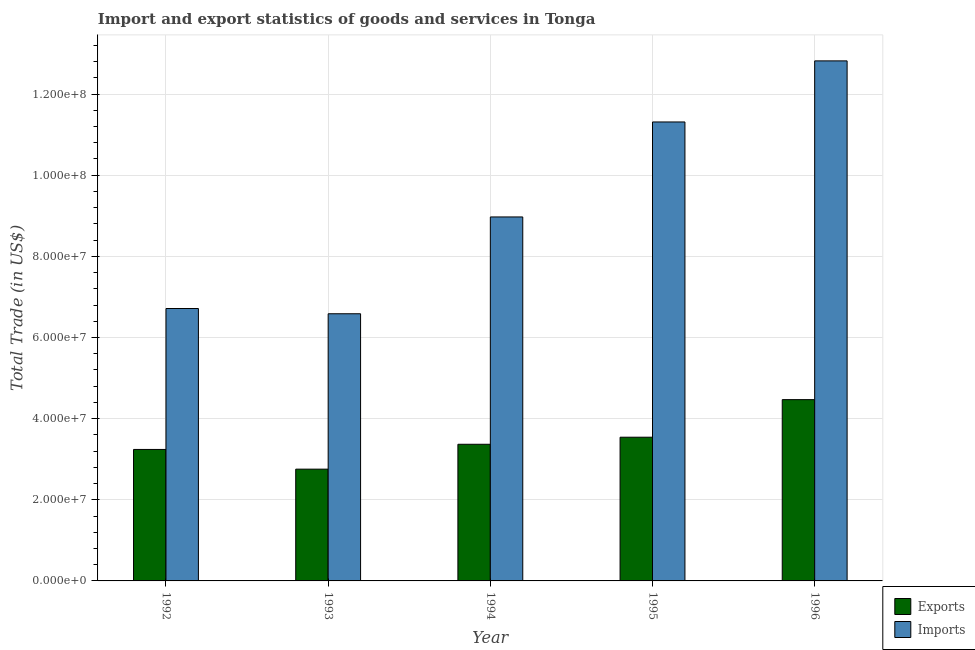Are the number of bars per tick equal to the number of legend labels?
Ensure brevity in your answer.  Yes. How many bars are there on the 1st tick from the left?
Ensure brevity in your answer.  2. How many bars are there on the 3rd tick from the right?
Your response must be concise. 2. What is the imports of goods and services in 1993?
Ensure brevity in your answer.  6.59e+07. Across all years, what is the maximum imports of goods and services?
Make the answer very short. 1.28e+08. Across all years, what is the minimum export of goods and services?
Keep it short and to the point. 2.76e+07. What is the total export of goods and services in the graph?
Offer a terse response. 1.74e+08. What is the difference between the imports of goods and services in 1993 and that in 1996?
Give a very brief answer. -6.23e+07. What is the difference between the export of goods and services in 1994 and the imports of goods and services in 1996?
Offer a very short reply. -1.10e+07. What is the average imports of goods and services per year?
Your response must be concise. 9.28e+07. In how many years, is the imports of goods and services greater than 20000000 US$?
Your answer should be very brief. 5. What is the ratio of the export of goods and services in 1995 to that in 1996?
Make the answer very short. 0.79. Is the export of goods and services in 1995 less than that in 1996?
Give a very brief answer. Yes. What is the difference between the highest and the second highest imports of goods and services?
Keep it short and to the point. 1.51e+07. What is the difference between the highest and the lowest imports of goods and services?
Offer a terse response. 6.23e+07. In how many years, is the export of goods and services greater than the average export of goods and services taken over all years?
Provide a short and direct response. 2. Is the sum of the imports of goods and services in 1992 and 1996 greater than the maximum export of goods and services across all years?
Your response must be concise. Yes. What does the 2nd bar from the left in 1992 represents?
Your answer should be compact. Imports. What does the 1st bar from the right in 1996 represents?
Your answer should be very brief. Imports. How many bars are there?
Your answer should be compact. 10. How many years are there in the graph?
Your response must be concise. 5. Are the values on the major ticks of Y-axis written in scientific E-notation?
Your answer should be compact. Yes. How many legend labels are there?
Ensure brevity in your answer.  2. How are the legend labels stacked?
Provide a short and direct response. Vertical. What is the title of the graph?
Ensure brevity in your answer.  Import and export statistics of goods and services in Tonga. What is the label or title of the Y-axis?
Keep it short and to the point. Total Trade (in US$). What is the Total Trade (in US$) of Exports in 1992?
Provide a succinct answer. 3.24e+07. What is the Total Trade (in US$) in Imports in 1992?
Provide a short and direct response. 6.71e+07. What is the Total Trade (in US$) in Exports in 1993?
Your answer should be very brief. 2.76e+07. What is the Total Trade (in US$) in Imports in 1993?
Offer a very short reply. 6.59e+07. What is the Total Trade (in US$) in Exports in 1994?
Provide a succinct answer. 3.37e+07. What is the Total Trade (in US$) of Imports in 1994?
Your answer should be very brief. 8.97e+07. What is the Total Trade (in US$) in Exports in 1995?
Offer a very short reply. 3.54e+07. What is the Total Trade (in US$) in Imports in 1995?
Your answer should be very brief. 1.13e+08. What is the Total Trade (in US$) in Exports in 1996?
Your response must be concise. 4.47e+07. What is the Total Trade (in US$) in Imports in 1996?
Offer a terse response. 1.28e+08. Across all years, what is the maximum Total Trade (in US$) of Exports?
Offer a very short reply. 4.47e+07. Across all years, what is the maximum Total Trade (in US$) of Imports?
Make the answer very short. 1.28e+08. Across all years, what is the minimum Total Trade (in US$) in Exports?
Offer a very short reply. 2.76e+07. Across all years, what is the minimum Total Trade (in US$) in Imports?
Make the answer very short. 6.59e+07. What is the total Total Trade (in US$) in Exports in the graph?
Ensure brevity in your answer.  1.74e+08. What is the total Total Trade (in US$) in Imports in the graph?
Offer a very short reply. 4.64e+08. What is the difference between the Total Trade (in US$) of Exports in 1992 and that in 1993?
Ensure brevity in your answer.  4.85e+06. What is the difference between the Total Trade (in US$) of Imports in 1992 and that in 1993?
Your answer should be very brief. 1.30e+06. What is the difference between the Total Trade (in US$) in Exports in 1992 and that in 1994?
Offer a very short reply. -1.28e+06. What is the difference between the Total Trade (in US$) of Imports in 1992 and that in 1994?
Provide a short and direct response. -2.26e+07. What is the difference between the Total Trade (in US$) in Exports in 1992 and that in 1995?
Give a very brief answer. -3.02e+06. What is the difference between the Total Trade (in US$) of Imports in 1992 and that in 1995?
Ensure brevity in your answer.  -4.60e+07. What is the difference between the Total Trade (in US$) of Exports in 1992 and that in 1996?
Offer a terse response. -1.23e+07. What is the difference between the Total Trade (in US$) in Imports in 1992 and that in 1996?
Make the answer very short. -6.10e+07. What is the difference between the Total Trade (in US$) in Exports in 1993 and that in 1994?
Ensure brevity in your answer.  -6.13e+06. What is the difference between the Total Trade (in US$) in Imports in 1993 and that in 1994?
Your answer should be very brief. -2.39e+07. What is the difference between the Total Trade (in US$) in Exports in 1993 and that in 1995?
Make the answer very short. -7.87e+06. What is the difference between the Total Trade (in US$) in Imports in 1993 and that in 1995?
Your answer should be very brief. -4.73e+07. What is the difference between the Total Trade (in US$) of Exports in 1993 and that in 1996?
Make the answer very short. -1.71e+07. What is the difference between the Total Trade (in US$) in Imports in 1993 and that in 1996?
Offer a terse response. -6.23e+07. What is the difference between the Total Trade (in US$) in Exports in 1994 and that in 1995?
Your response must be concise. -1.74e+06. What is the difference between the Total Trade (in US$) in Imports in 1994 and that in 1995?
Your response must be concise. -2.34e+07. What is the difference between the Total Trade (in US$) of Exports in 1994 and that in 1996?
Make the answer very short. -1.10e+07. What is the difference between the Total Trade (in US$) of Imports in 1994 and that in 1996?
Give a very brief answer. -3.85e+07. What is the difference between the Total Trade (in US$) in Exports in 1995 and that in 1996?
Make the answer very short. -9.26e+06. What is the difference between the Total Trade (in US$) of Imports in 1995 and that in 1996?
Your response must be concise. -1.51e+07. What is the difference between the Total Trade (in US$) of Exports in 1992 and the Total Trade (in US$) of Imports in 1993?
Make the answer very short. -3.34e+07. What is the difference between the Total Trade (in US$) of Exports in 1992 and the Total Trade (in US$) of Imports in 1994?
Make the answer very short. -5.73e+07. What is the difference between the Total Trade (in US$) of Exports in 1992 and the Total Trade (in US$) of Imports in 1995?
Ensure brevity in your answer.  -8.07e+07. What is the difference between the Total Trade (in US$) in Exports in 1992 and the Total Trade (in US$) in Imports in 1996?
Ensure brevity in your answer.  -9.58e+07. What is the difference between the Total Trade (in US$) in Exports in 1993 and the Total Trade (in US$) in Imports in 1994?
Offer a very short reply. -6.22e+07. What is the difference between the Total Trade (in US$) of Exports in 1993 and the Total Trade (in US$) of Imports in 1995?
Your answer should be very brief. -8.56e+07. What is the difference between the Total Trade (in US$) in Exports in 1993 and the Total Trade (in US$) in Imports in 1996?
Offer a very short reply. -1.01e+08. What is the difference between the Total Trade (in US$) in Exports in 1994 and the Total Trade (in US$) in Imports in 1995?
Make the answer very short. -7.94e+07. What is the difference between the Total Trade (in US$) of Exports in 1994 and the Total Trade (in US$) of Imports in 1996?
Provide a succinct answer. -9.45e+07. What is the difference between the Total Trade (in US$) of Exports in 1995 and the Total Trade (in US$) of Imports in 1996?
Provide a short and direct response. -9.28e+07. What is the average Total Trade (in US$) of Exports per year?
Offer a very short reply. 3.47e+07. What is the average Total Trade (in US$) of Imports per year?
Provide a short and direct response. 9.28e+07. In the year 1992, what is the difference between the Total Trade (in US$) in Exports and Total Trade (in US$) in Imports?
Make the answer very short. -3.47e+07. In the year 1993, what is the difference between the Total Trade (in US$) of Exports and Total Trade (in US$) of Imports?
Provide a short and direct response. -3.83e+07. In the year 1994, what is the difference between the Total Trade (in US$) in Exports and Total Trade (in US$) in Imports?
Keep it short and to the point. -5.60e+07. In the year 1995, what is the difference between the Total Trade (in US$) in Exports and Total Trade (in US$) in Imports?
Provide a succinct answer. -7.77e+07. In the year 1996, what is the difference between the Total Trade (in US$) in Exports and Total Trade (in US$) in Imports?
Offer a terse response. -8.35e+07. What is the ratio of the Total Trade (in US$) of Exports in 1992 to that in 1993?
Offer a very short reply. 1.18. What is the ratio of the Total Trade (in US$) in Imports in 1992 to that in 1993?
Your response must be concise. 1.02. What is the ratio of the Total Trade (in US$) in Exports in 1992 to that in 1994?
Make the answer very short. 0.96. What is the ratio of the Total Trade (in US$) of Imports in 1992 to that in 1994?
Make the answer very short. 0.75. What is the ratio of the Total Trade (in US$) of Exports in 1992 to that in 1995?
Your answer should be very brief. 0.91. What is the ratio of the Total Trade (in US$) of Imports in 1992 to that in 1995?
Provide a short and direct response. 0.59. What is the ratio of the Total Trade (in US$) in Exports in 1992 to that in 1996?
Offer a terse response. 0.73. What is the ratio of the Total Trade (in US$) in Imports in 1992 to that in 1996?
Ensure brevity in your answer.  0.52. What is the ratio of the Total Trade (in US$) in Exports in 1993 to that in 1994?
Ensure brevity in your answer.  0.82. What is the ratio of the Total Trade (in US$) of Imports in 1993 to that in 1994?
Your answer should be compact. 0.73. What is the ratio of the Total Trade (in US$) in Exports in 1993 to that in 1995?
Offer a terse response. 0.78. What is the ratio of the Total Trade (in US$) in Imports in 1993 to that in 1995?
Make the answer very short. 0.58. What is the ratio of the Total Trade (in US$) of Exports in 1993 to that in 1996?
Keep it short and to the point. 0.62. What is the ratio of the Total Trade (in US$) in Imports in 1993 to that in 1996?
Provide a succinct answer. 0.51. What is the ratio of the Total Trade (in US$) of Exports in 1994 to that in 1995?
Your answer should be very brief. 0.95. What is the ratio of the Total Trade (in US$) of Imports in 1994 to that in 1995?
Your answer should be very brief. 0.79. What is the ratio of the Total Trade (in US$) of Exports in 1994 to that in 1996?
Ensure brevity in your answer.  0.75. What is the ratio of the Total Trade (in US$) in Imports in 1994 to that in 1996?
Your response must be concise. 0.7. What is the ratio of the Total Trade (in US$) of Exports in 1995 to that in 1996?
Give a very brief answer. 0.79. What is the ratio of the Total Trade (in US$) in Imports in 1995 to that in 1996?
Your answer should be very brief. 0.88. What is the difference between the highest and the second highest Total Trade (in US$) of Exports?
Give a very brief answer. 9.26e+06. What is the difference between the highest and the second highest Total Trade (in US$) of Imports?
Ensure brevity in your answer.  1.51e+07. What is the difference between the highest and the lowest Total Trade (in US$) of Exports?
Your answer should be compact. 1.71e+07. What is the difference between the highest and the lowest Total Trade (in US$) of Imports?
Ensure brevity in your answer.  6.23e+07. 